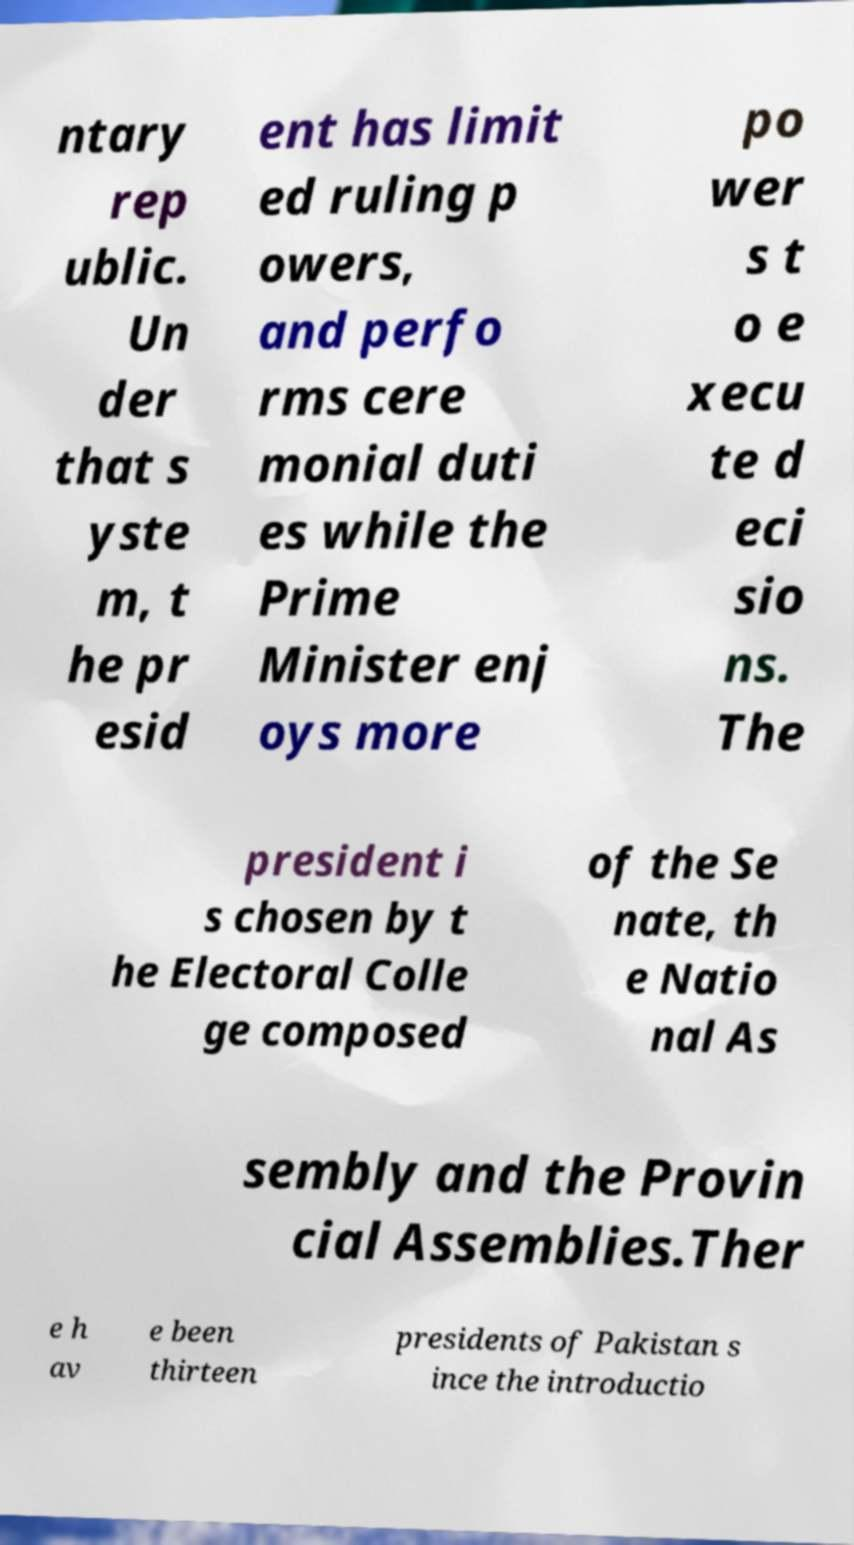I need the written content from this picture converted into text. Can you do that? ntary rep ublic. Un der that s yste m, t he pr esid ent has limit ed ruling p owers, and perfo rms cere monial duti es while the Prime Minister enj oys more po wer s t o e xecu te d eci sio ns. The president i s chosen by t he Electoral Colle ge composed of the Se nate, th e Natio nal As sembly and the Provin cial Assemblies.Ther e h av e been thirteen presidents of Pakistan s ince the introductio 